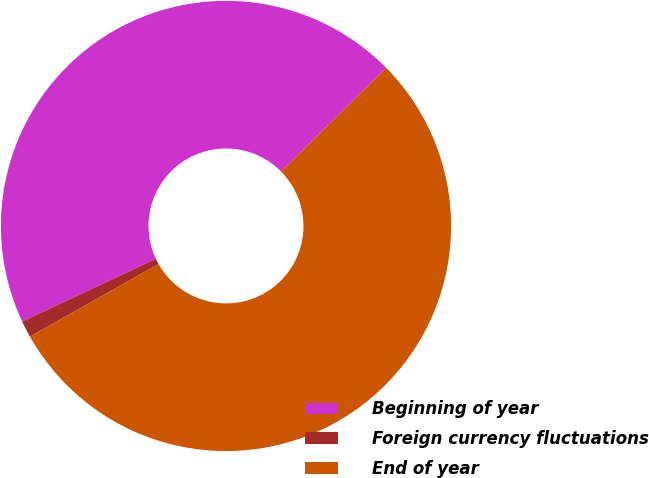Convert chart. <chart><loc_0><loc_0><loc_500><loc_500><pie_chart><fcel>Beginning of year<fcel>Foreign currency fluctuations<fcel>End of year<nl><fcel>44.58%<fcel>1.2%<fcel>54.22%<nl></chart> 